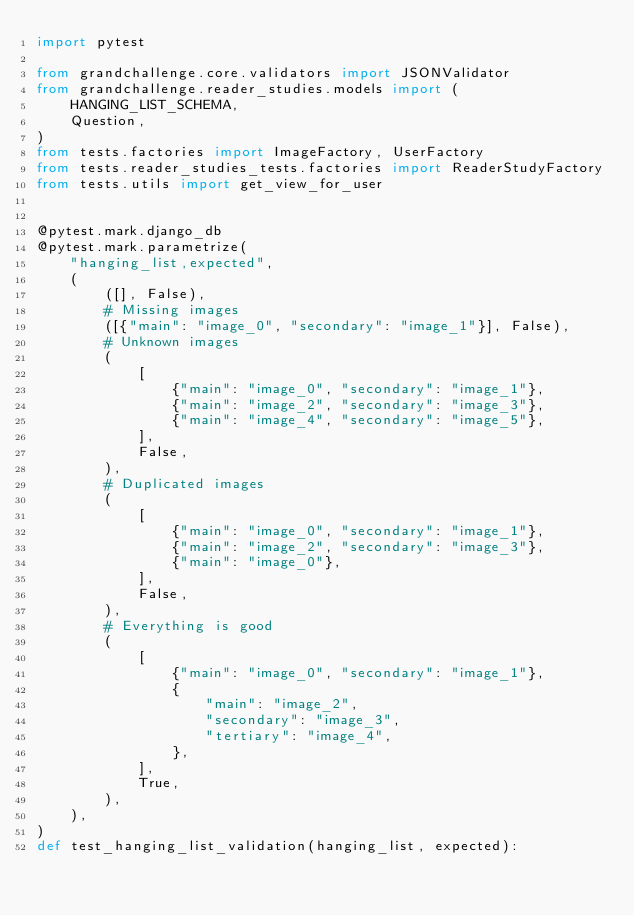<code> <loc_0><loc_0><loc_500><loc_500><_Python_>import pytest

from grandchallenge.core.validators import JSONValidator
from grandchallenge.reader_studies.models import (
    HANGING_LIST_SCHEMA,
    Question,
)
from tests.factories import ImageFactory, UserFactory
from tests.reader_studies_tests.factories import ReaderStudyFactory
from tests.utils import get_view_for_user


@pytest.mark.django_db
@pytest.mark.parametrize(
    "hanging_list,expected",
    (
        ([], False),
        # Missing images
        ([{"main": "image_0", "secondary": "image_1"}], False),
        # Unknown images
        (
            [
                {"main": "image_0", "secondary": "image_1"},
                {"main": "image_2", "secondary": "image_3"},
                {"main": "image_4", "secondary": "image_5"},
            ],
            False,
        ),
        # Duplicated images
        (
            [
                {"main": "image_0", "secondary": "image_1"},
                {"main": "image_2", "secondary": "image_3"},
                {"main": "image_0"},
            ],
            False,
        ),
        # Everything is good
        (
            [
                {"main": "image_0", "secondary": "image_1"},
                {
                    "main": "image_2",
                    "secondary": "image_3",
                    "tertiary": "image_4",
                },
            ],
            True,
        ),
    ),
)
def test_hanging_list_validation(hanging_list, expected):</code> 